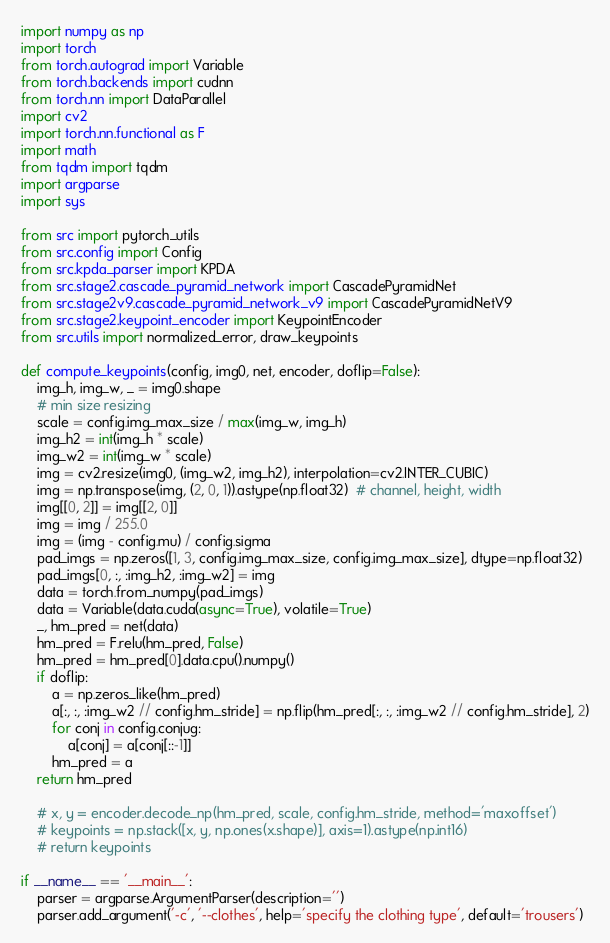Convert code to text. <code><loc_0><loc_0><loc_500><loc_500><_Python_>import numpy as np
import torch
from torch.autograd import Variable
from torch.backends import cudnn
from torch.nn import DataParallel
import cv2
import torch.nn.functional as F
import math
from tqdm import tqdm
import argparse
import sys

from src import pytorch_utils
from src.config import Config
from src.kpda_parser import KPDA
from src.stage2.cascade_pyramid_network import CascadePyramidNet
from src.stage2v9.cascade_pyramid_network_v9 import CascadePyramidNetV9
from src.stage2.keypoint_encoder import KeypointEncoder
from src.utils import normalized_error, draw_keypoints

def compute_keypoints(config, img0, net, encoder, doflip=False):
    img_h, img_w, _ = img0.shape
    # min size resizing
    scale = config.img_max_size / max(img_w, img_h)
    img_h2 = int(img_h * scale)
    img_w2 = int(img_w * scale)
    img = cv2.resize(img0, (img_w2, img_h2), interpolation=cv2.INTER_CUBIC)
    img = np.transpose(img, (2, 0, 1)).astype(np.float32)  # channel, height, width
    img[[0, 2]] = img[[2, 0]]
    img = img / 255.0
    img = (img - config.mu) / config.sigma
    pad_imgs = np.zeros([1, 3, config.img_max_size, config.img_max_size], dtype=np.float32)
    pad_imgs[0, :, :img_h2, :img_w2] = img
    data = torch.from_numpy(pad_imgs)
    data = Variable(data.cuda(async=True), volatile=True)
    _, hm_pred = net(data)
    hm_pred = F.relu(hm_pred, False)
    hm_pred = hm_pred[0].data.cpu().numpy()
    if doflip:
        a = np.zeros_like(hm_pred)
        a[:, :, :img_w2 // config.hm_stride] = np.flip(hm_pred[:, :, :img_w2 // config.hm_stride], 2)
        for conj in config.conjug:
            a[conj] = a[conj[::-1]]
        hm_pred = a
    return hm_pred

    # x, y = encoder.decode_np(hm_pred, scale, config.hm_stride, method='maxoffset')
    # keypoints = np.stack([x, y, np.ones(x.shape)], axis=1).astype(np.int16)
    # return keypoints

if __name__ == '__main__':
    parser = argparse.ArgumentParser(description='')
    parser.add_argument('-c', '--clothes', help='specify the clothing type', default='trousers')</code> 